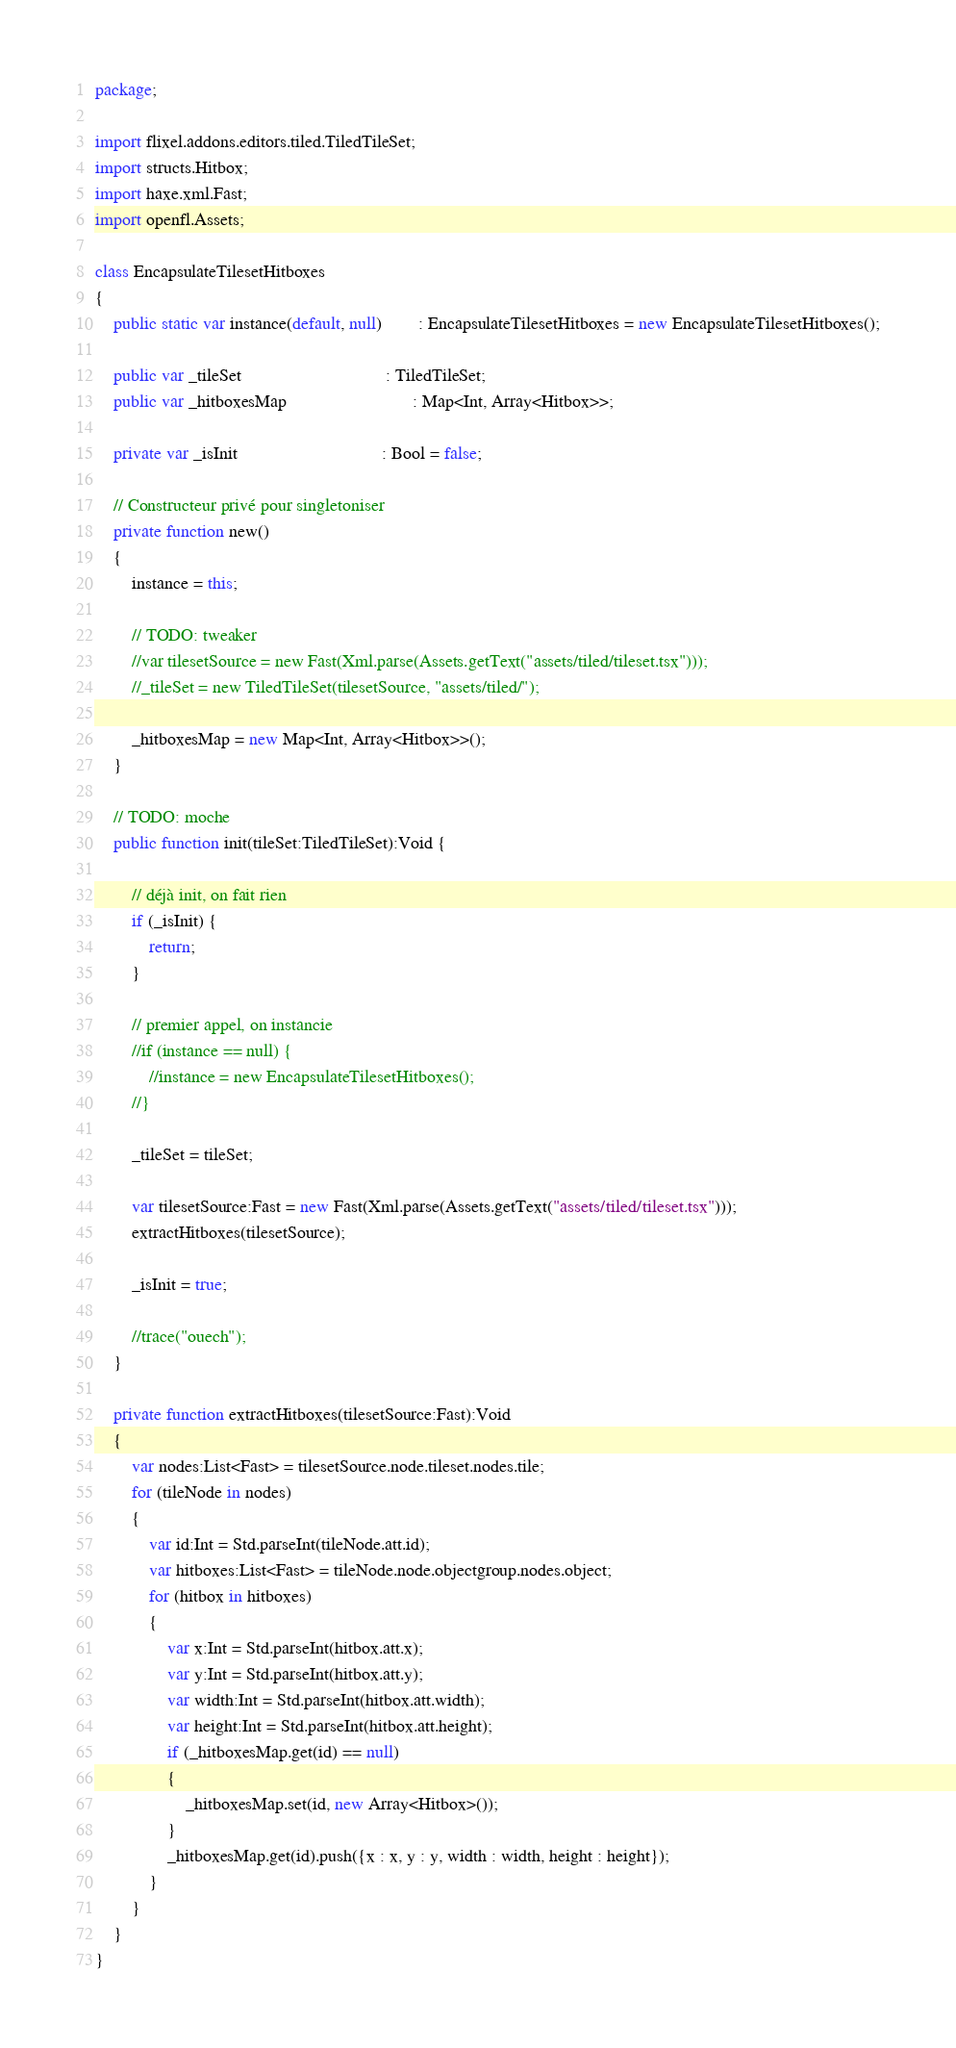<code> <loc_0><loc_0><loc_500><loc_500><_Haxe_>package;

import flixel.addons.editors.tiled.TiledTileSet;
import structs.Hitbox;
import haxe.xml.Fast;
import openfl.Assets;

class EncapsulateTilesetHitboxes
{
	public static var instance(default, null)		: EncapsulateTilesetHitboxes = new EncapsulateTilesetHitboxes();

	public var _tileSet								: TiledTileSet;
	public var _hitboxesMap							: Map<Int, Array<Hitbox>>;
	
	private var _isInit								: Bool = false;

	// Constructeur privé pour singletoniser
	private function new()
	{
		instance = this;
		
		// TODO: tweaker
		//var tilesetSource = new Fast(Xml.parse(Assets.getText("assets/tiled/tileset.tsx")));
		//_tileSet = new TiledTileSet(tilesetSource, "assets/tiled/");
		
		_hitboxesMap = new Map<Int, Array<Hitbox>>();
	}
	
	// TODO: moche
	public function init(tileSet:TiledTileSet):Void {
		
		// déjà init, on fait rien
		if (_isInit) {
			return;
		}
		
		// premier appel, on instancie
		//if (instance == null) {
			//instance = new EncapsulateTilesetHitboxes();
		//}
		
		_tileSet = tileSet;
		
		var tilesetSource:Fast = new Fast(Xml.parse(Assets.getText("assets/tiled/tileset.tsx")));
		extractHitboxes(tilesetSource);
		
		_isInit = true;
		
		//trace("ouech");
	}
	
	private function extractHitboxes(tilesetSource:Fast):Void
	{
		var nodes:List<Fast> = tilesetSource.node.tileset.nodes.tile;
		for (tileNode in nodes)
		{
			var id:Int = Std.parseInt(tileNode.att.id);
			var hitboxes:List<Fast> = tileNode.node.objectgroup.nodes.object;
			for (hitbox in hitboxes)
			{
				var x:Int = Std.parseInt(hitbox.att.x);
				var y:Int = Std.parseInt(hitbox.att.y);
				var width:Int = Std.parseInt(hitbox.att.width);
				var height:Int = Std.parseInt(hitbox.att.height);
				if (_hitboxesMap.get(id) == null)
				{
					_hitboxesMap.set(id, new Array<Hitbox>());
				}
				_hitboxesMap.get(id).push({x : x, y : y, width : width, height : height});
			}
		}
	}
}</code> 